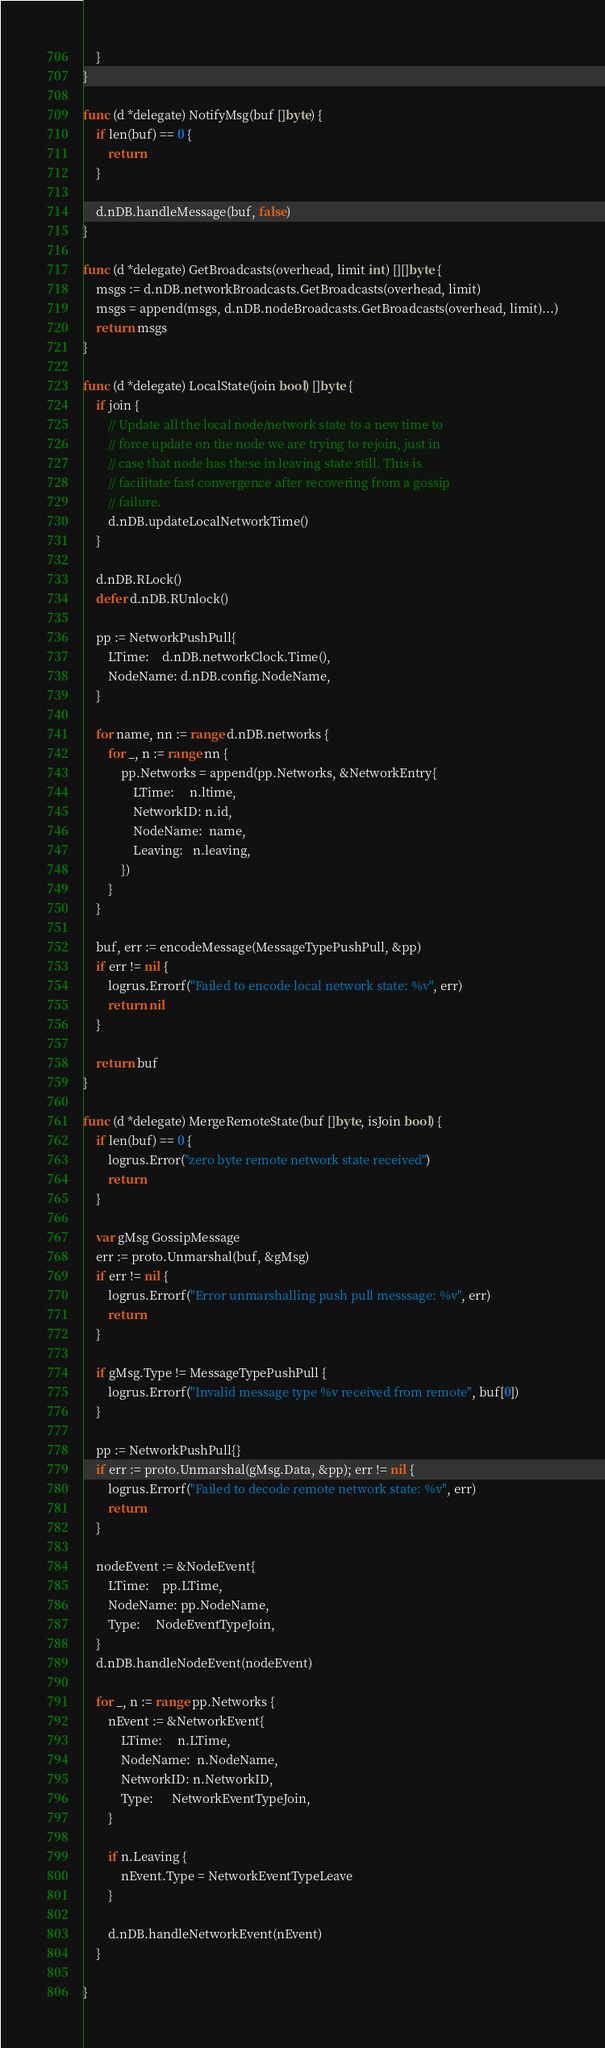<code> <loc_0><loc_0><loc_500><loc_500><_Go_>	}
}

func (d *delegate) NotifyMsg(buf []byte) {
	if len(buf) == 0 {
		return
	}

	d.nDB.handleMessage(buf, false)
}

func (d *delegate) GetBroadcasts(overhead, limit int) [][]byte {
	msgs := d.nDB.networkBroadcasts.GetBroadcasts(overhead, limit)
	msgs = append(msgs, d.nDB.nodeBroadcasts.GetBroadcasts(overhead, limit)...)
	return msgs
}

func (d *delegate) LocalState(join bool) []byte {
	if join {
		// Update all the local node/network state to a new time to
		// force update on the node we are trying to rejoin, just in
		// case that node has these in leaving state still. This is
		// facilitate fast convergence after recovering from a gossip
		// failure.
		d.nDB.updateLocalNetworkTime()
	}

	d.nDB.RLock()
	defer d.nDB.RUnlock()

	pp := NetworkPushPull{
		LTime:    d.nDB.networkClock.Time(),
		NodeName: d.nDB.config.NodeName,
	}

	for name, nn := range d.nDB.networks {
		for _, n := range nn {
			pp.Networks = append(pp.Networks, &NetworkEntry{
				LTime:     n.ltime,
				NetworkID: n.id,
				NodeName:  name,
				Leaving:   n.leaving,
			})
		}
	}

	buf, err := encodeMessage(MessageTypePushPull, &pp)
	if err != nil {
		logrus.Errorf("Failed to encode local network state: %v", err)
		return nil
	}

	return buf
}

func (d *delegate) MergeRemoteState(buf []byte, isJoin bool) {
	if len(buf) == 0 {
		logrus.Error("zero byte remote network state received")
		return
	}

	var gMsg GossipMessage
	err := proto.Unmarshal(buf, &gMsg)
	if err != nil {
		logrus.Errorf("Error unmarshalling push pull messsage: %v", err)
		return
	}

	if gMsg.Type != MessageTypePushPull {
		logrus.Errorf("Invalid message type %v received from remote", buf[0])
	}

	pp := NetworkPushPull{}
	if err := proto.Unmarshal(gMsg.Data, &pp); err != nil {
		logrus.Errorf("Failed to decode remote network state: %v", err)
		return
	}

	nodeEvent := &NodeEvent{
		LTime:    pp.LTime,
		NodeName: pp.NodeName,
		Type:     NodeEventTypeJoin,
	}
	d.nDB.handleNodeEvent(nodeEvent)

	for _, n := range pp.Networks {
		nEvent := &NetworkEvent{
			LTime:     n.LTime,
			NodeName:  n.NodeName,
			NetworkID: n.NetworkID,
			Type:      NetworkEventTypeJoin,
		}

		if n.Leaving {
			nEvent.Type = NetworkEventTypeLeave
		}

		d.nDB.handleNetworkEvent(nEvent)
	}

}
</code> 